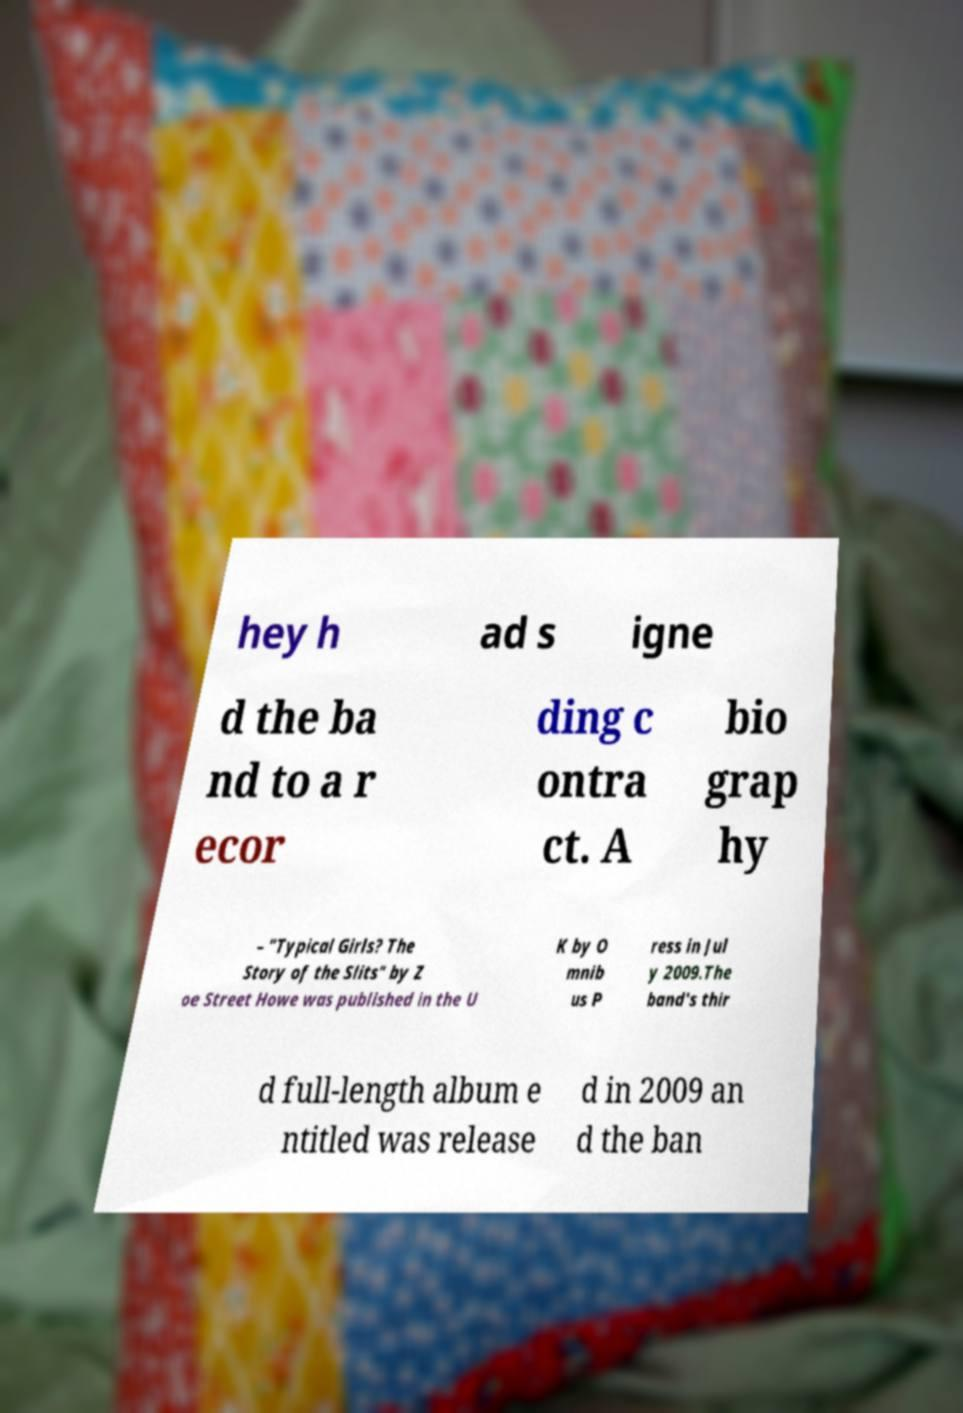Can you accurately transcribe the text from the provided image for me? hey h ad s igne d the ba nd to a r ecor ding c ontra ct. A bio grap hy – "Typical Girls? The Story of the Slits" by Z oe Street Howe was published in the U K by O mnib us P ress in Jul y 2009.The band's thir d full-length album e ntitled was release d in 2009 an d the ban 